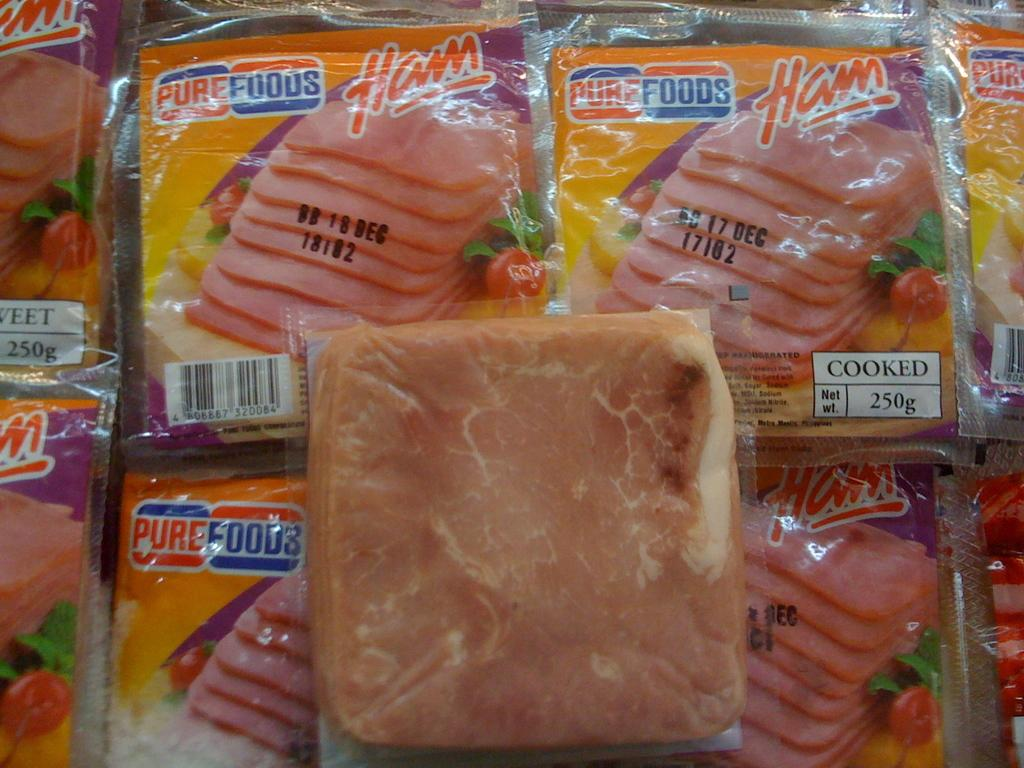What is located in the center of the image? There are packets in the center of the image. What can be found inside the packets? The packets contain food items. Is there any text or information on the packets? Yes, there is writing on the packets. How many snakes are wrapped around the packets in the image? There are no snakes present in the image. What type of wrist accessory is visible on the packets in the image? There is no wrist accessory visible on the packets in the image. 